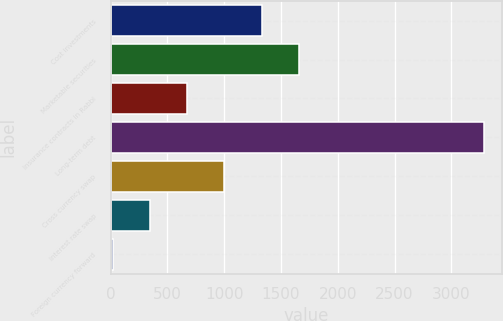<chart> <loc_0><loc_0><loc_500><loc_500><bar_chart><fcel>Cost investments<fcel>Marketable securities<fcel>Insurance contracts in Rabbi<fcel>Long-term debt<fcel>Cross currency swap<fcel>Interest rate swap<fcel>Foreign currency forward<nl><fcel>1328.6<fcel>1654.5<fcel>676.8<fcel>3284<fcel>1002.7<fcel>350.9<fcel>25<nl></chart> 